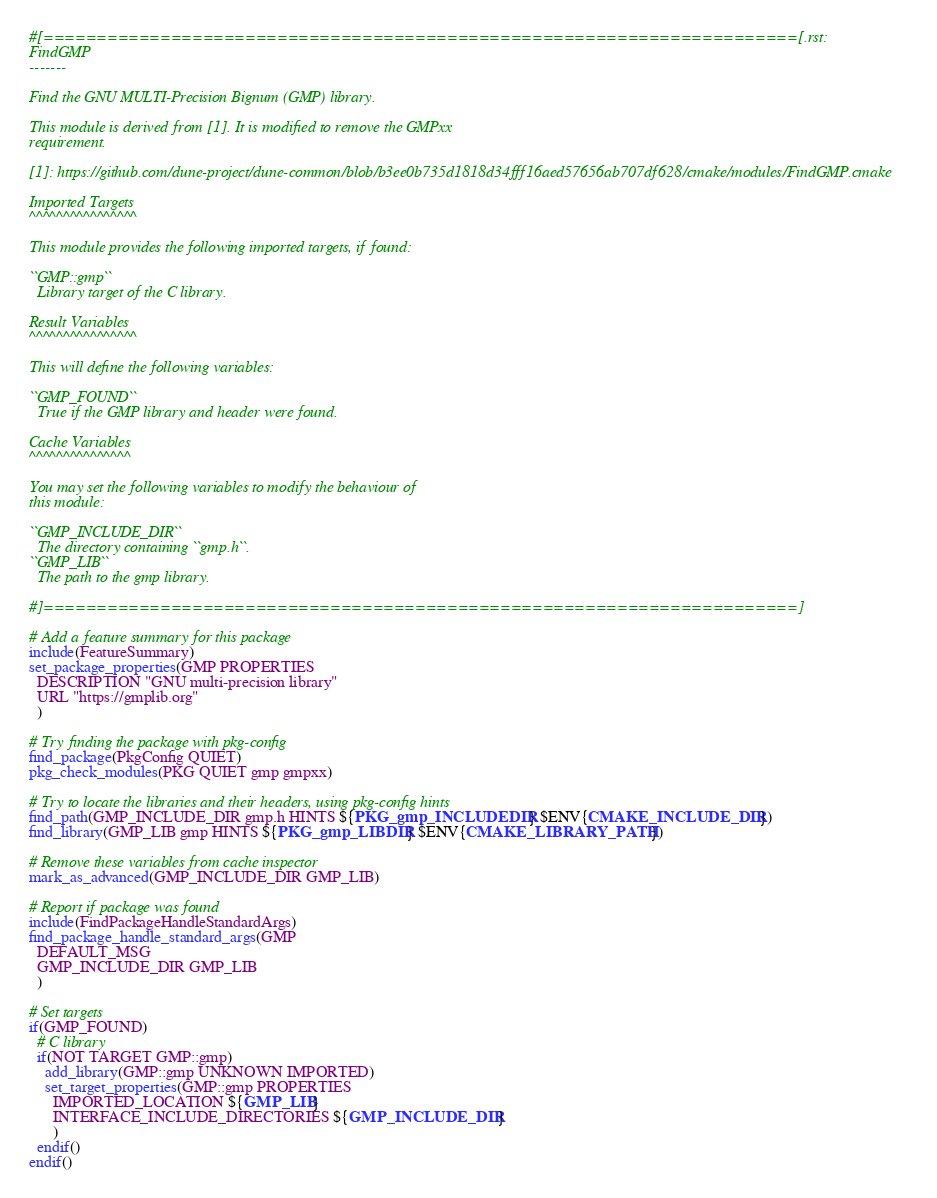Convert code to text. <code><loc_0><loc_0><loc_500><loc_500><_CMake_>#[=======================================================================[.rst:
FindGMP
-------

Find the GNU MULTI-Precision Bignum (GMP) library.

This module is derived from [1]. It is modified to remove the GMPxx
requirement.

[1]: https://github.com/dune-project/dune-common/blob/b3ee0b735d1818d34fff16aed57656ab707df628/cmake/modules/FindGMP.cmake

Imported Targets
^^^^^^^^^^^^^^^^

This module provides the following imported targets, if found:

``GMP::gmp``
  Library target of the C library.

Result Variables
^^^^^^^^^^^^^^^^

This will define the following variables:

``GMP_FOUND``
  True if the GMP library and header were found.

Cache Variables
^^^^^^^^^^^^^^^

You may set the following variables to modify the behaviour of
this module:

``GMP_INCLUDE_DIR``
  The directory containing ``gmp.h``.
``GMP_LIB``
  The path to the gmp library.

#]=======================================================================]

# Add a feature summary for this package
include(FeatureSummary)
set_package_properties(GMP PROPERTIES
  DESCRIPTION "GNU multi-precision library"
  URL "https://gmplib.org"
  )

# Try finding the package with pkg-config
find_package(PkgConfig QUIET)
pkg_check_modules(PKG QUIET gmp gmpxx)

# Try to locate the libraries and their headers, using pkg-config hints
find_path(GMP_INCLUDE_DIR gmp.h HINTS ${PKG_gmp_INCLUDEDIR} $ENV{CMAKE_INCLUDE_DIR})
find_library(GMP_LIB gmp HINTS ${PKG_gmp_LIBDIR} $ENV{CMAKE_LIBRARY_PATH})

# Remove these variables from cache inspector
mark_as_advanced(GMP_INCLUDE_DIR GMP_LIB)

# Report if package was found
include(FindPackageHandleStandardArgs)
find_package_handle_standard_args(GMP
  DEFAULT_MSG
  GMP_INCLUDE_DIR GMP_LIB
  )

# Set targets
if(GMP_FOUND)
  # C library
  if(NOT TARGET GMP::gmp)
    add_library(GMP::gmp UNKNOWN IMPORTED)
    set_target_properties(GMP::gmp PROPERTIES
      IMPORTED_LOCATION ${GMP_LIB}
      INTERFACE_INCLUDE_DIRECTORIES ${GMP_INCLUDE_DIR}
      )
  endif()
endif()
</code> 